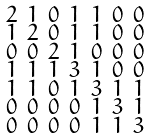<formula> <loc_0><loc_0><loc_500><loc_500>\begin{smallmatrix} 2 & 1 & 0 & 1 & 1 & 0 & 0 \\ 1 & 2 & 0 & 1 & 1 & 0 & 0 \\ 0 & 0 & 2 & 1 & 0 & 0 & 0 \\ 1 & 1 & 1 & 3 & 1 & 0 & 0 \\ 1 & 1 & 0 & 1 & 3 & 1 & 1 \\ 0 & 0 & 0 & 0 & 1 & 3 & 1 \\ 0 & 0 & 0 & 0 & 1 & 1 & 3 \end{smallmatrix}</formula> 